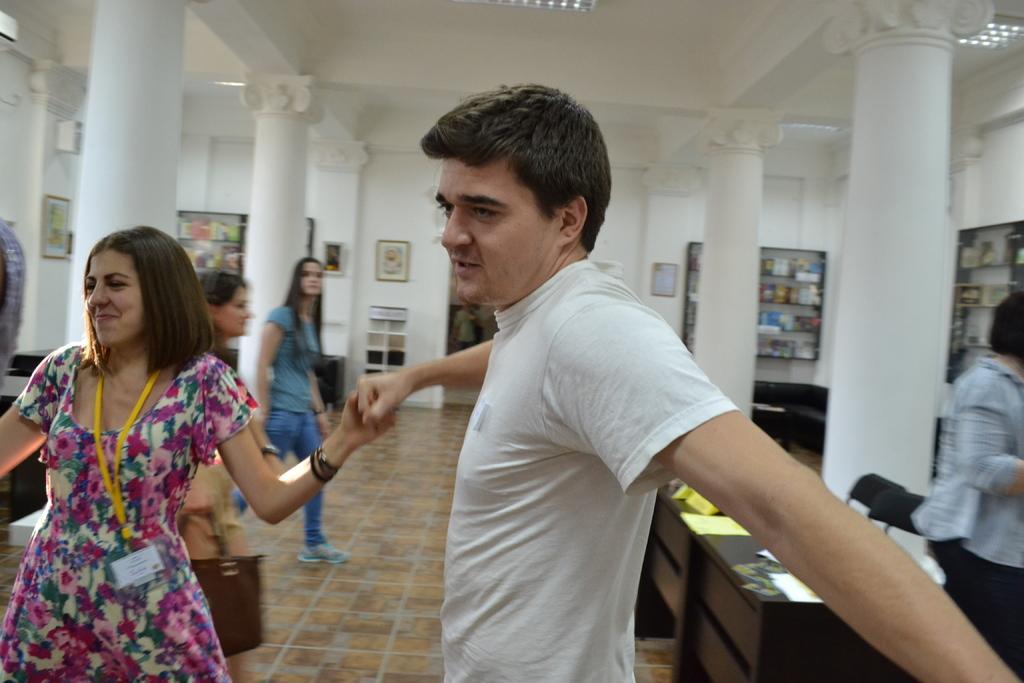In one or two sentences, can you explain what this image depicts? In this image there is a woman smiling and holding a hand of a man. In the background there are two women. On the right there is also one person. This image is taken inside the building and there are racks and frames are attached to the plain wall. At the bottom there is floor visible. Image also consists of a wooden table and on the table there are papers placed. 